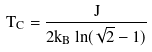<formula> <loc_0><loc_0><loc_500><loc_500>T _ { C } = \frac { J } { 2 k _ { B } \ln ( \sqrt { 2 } - 1 ) }</formula> 